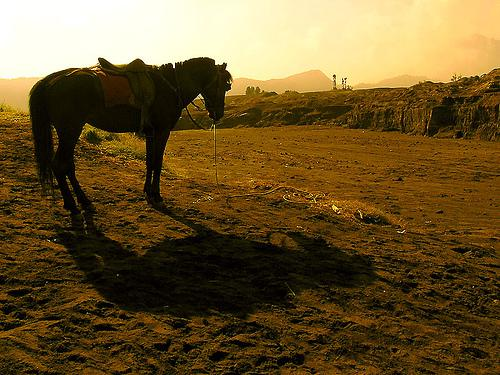Question: who is in the picture?
Choices:
A. A dog.
B. A horse.
C. A person.
D. A cat.
Answer with the letter. Answer: B Question: what is on the horses face?
Choices:
A. White spot.
B. Brown spot.
C. Bridle.
D. Hair.
Answer with the letter. Answer: C Question: what is it standing on?
Choices:
A. The ground.
B. The chair.
C. The dirt.
D. The road.
Answer with the letter. Answer: A Question: why is there a saddle?
Choices:
A. For rider.
B. For safety.
C. For demonstration.
D. For tricks.
Answer with the letter. Answer: A 